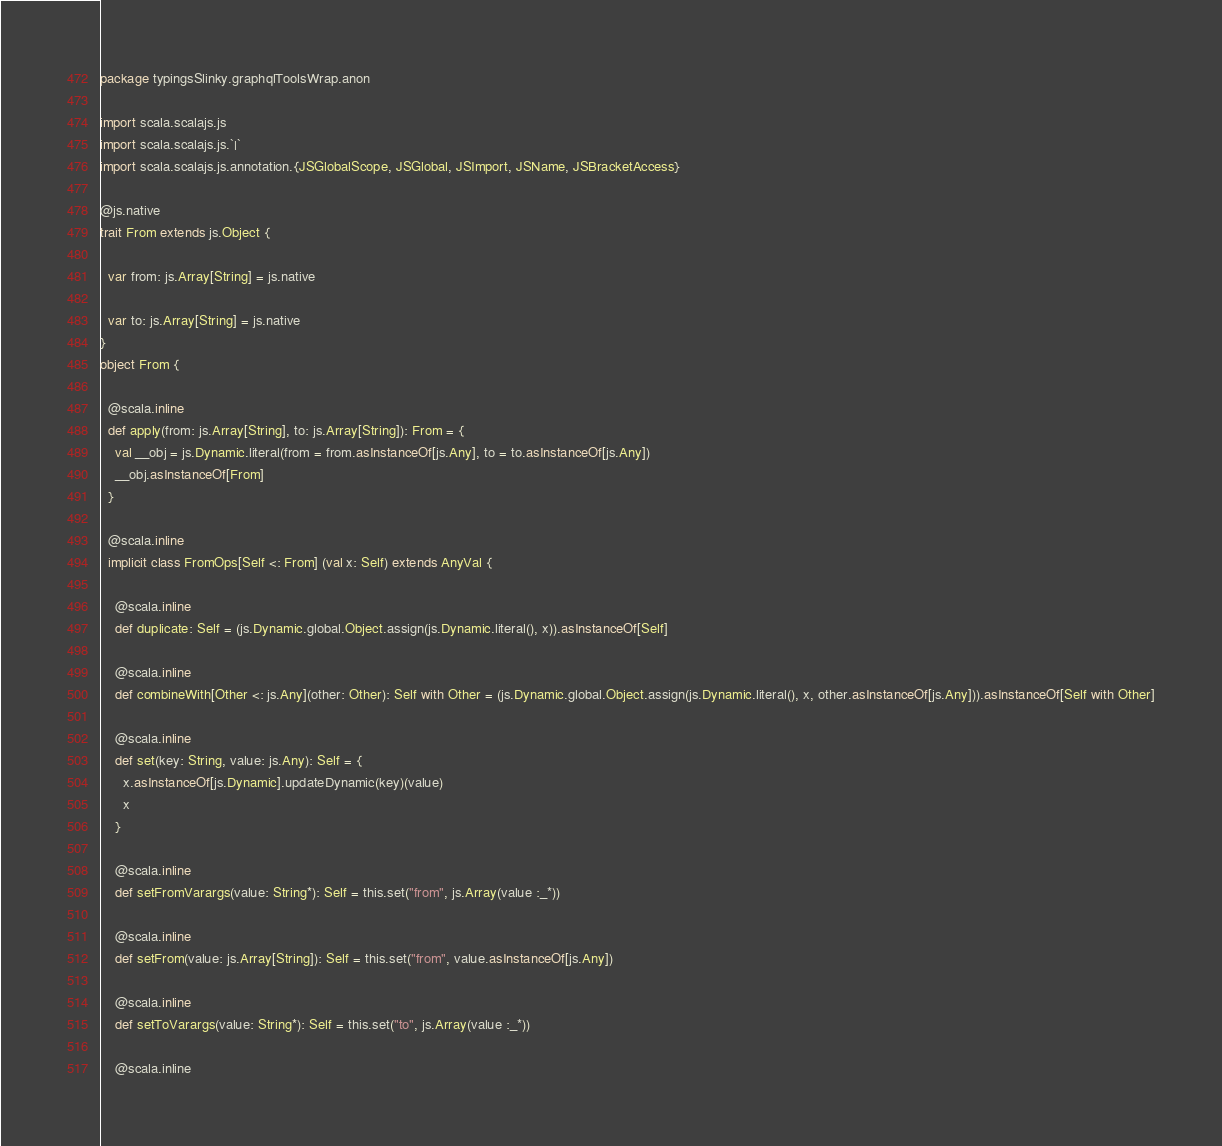<code> <loc_0><loc_0><loc_500><loc_500><_Scala_>package typingsSlinky.graphqlToolsWrap.anon

import scala.scalajs.js
import scala.scalajs.js.`|`
import scala.scalajs.js.annotation.{JSGlobalScope, JSGlobal, JSImport, JSName, JSBracketAccess}

@js.native
trait From extends js.Object {
  
  var from: js.Array[String] = js.native
  
  var to: js.Array[String] = js.native
}
object From {
  
  @scala.inline
  def apply(from: js.Array[String], to: js.Array[String]): From = {
    val __obj = js.Dynamic.literal(from = from.asInstanceOf[js.Any], to = to.asInstanceOf[js.Any])
    __obj.asInstanceOf[From]
  }
  
  @scala.inline
  implicit class FromOps[Self <: From] (val x: Self) extends AnyVal {
    
    @scala.inline
    def duplicate: Self = (js.Dynamic.global.Object.assign(js.Dynamic.literal(), x)).asInstanceOf[Self]
    
    @scala.inline
    def combineWith[Other <: js.Any](other: Other): Self with Other = (js.Dynamic.global.Object.assign(js.Dynamic.literal(), x, other.asInstanceOf[js.Any])).asInstanceOf[Self with Other]
    
    @scala.inline
    def set(key: String, value: js.Any): Self = {
      x.asInstanceOf[js.Dynamic].updateDynamic(key)(value)
      x
    }
    
    @scala.inline
    def setFromVarargs(value: String*): Self = this.set("from", js.Array(value :_*))
    
    @scala.inline
    def setFrom(value: js.Array[String]): Self = this.set("from", value.asInstanceOf[js.Any])
    
    @scala.inline
    def setToVarargs(value: String*): Self = this.set("to", js.Array(value :_*))
    
    @scala.inline</code> 